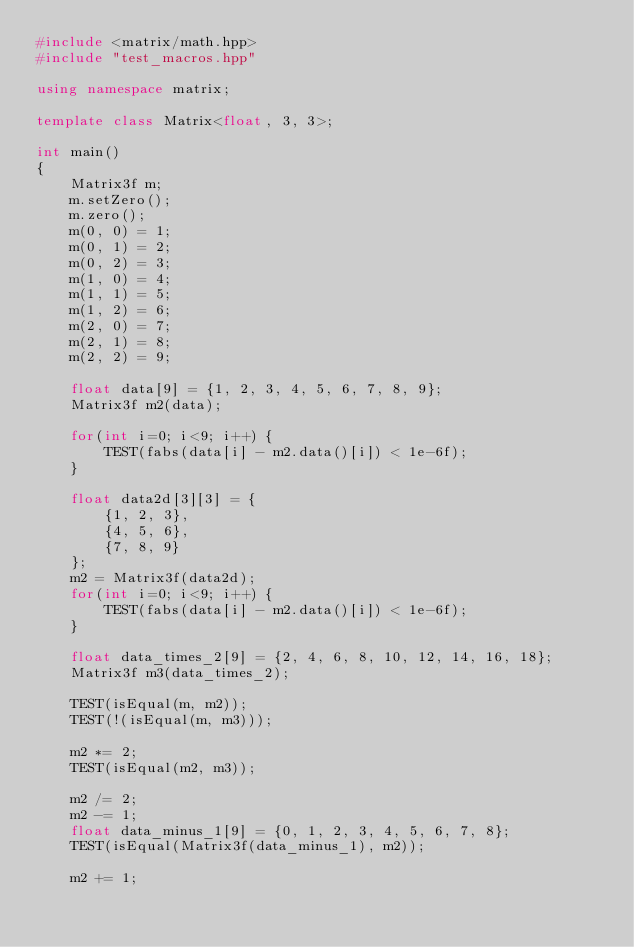<code> <loc_0><loc_0><loc_500><loc_500><_C++_>#include <matrix/math.hpp>
#include "test_macros.hpp"

using namespace matrix;

template class Matrix<float, 3, 3>;

int main()
{
    Matrix3f m;
    m.setZero();
    m.zero();
    m(0, 0) = 1;
    m(0, 1) = 2;
    m(0, 2) = 3;
    m(1, 0) = 4;
    m(1, 1) = 5;
    m(1, 2) = 6;
    m(2, 0) = 7;
    m(2, 1) = 8;
    m(2, 2) = 9;

    float data[9] = {1, 2, 3, 4, 5, 6, 7, 8, 9};
    Matrix3f m2(data);

    for(int i=0; i<9; i++) {
        TEST(fabs(data[i] - m2.data()[i]) < 1e-6f);
    }

    float data2d[3][3] = {
        {1, 2, 3},
        {4, 5, 6},
        {7, 8, 9}
    };
    m2 = Matrix3f(data2d);
    for(int i=0; i<9; i++) {
        TEST(fabs(data[i] - m2.data()[i]) < 1e-6f);
    }

    float data_times_2[9] = {2, 4, 6, 8, 10, 12, 14, 16, 18};
    Matrix3f m3(data_times_2);

    TEST(isEqual(m, m2));
    TEST(!(isEqual(m, m3)));

    m2 *= 2;
    TEST(isEqual(m2, m3));

    m2 /= 2;
    m2 -= 1;
    float data_minus_1[9] = {0, 1, 2, 3, 4, 5, 6, 7, 8};
    TEST(isEqual(Matrix3f(data_minus_1), m2));

    m2 += 1;</code> 